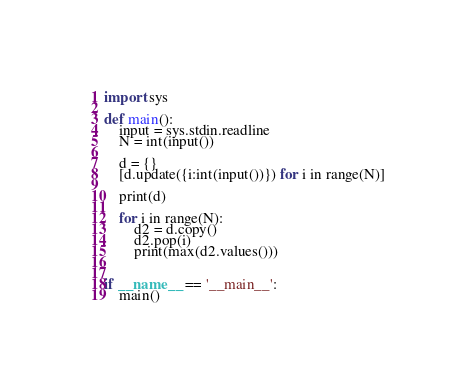<code> <loc_0><loc_0><loc_500><loc_500><_Python_>import sys

def main():
    input = sys.stdin.readline
    N = int(input())
    
    d = {}
    [d.update({i:int(input())}) for i in range(N)]
    
    print(d)
    
    for i in range(N):
        d2 = d.copy()
        d2.pop(i)
        print(max(d2.values()))
    
    
if __name__ == '__main__':
    main()</code> 